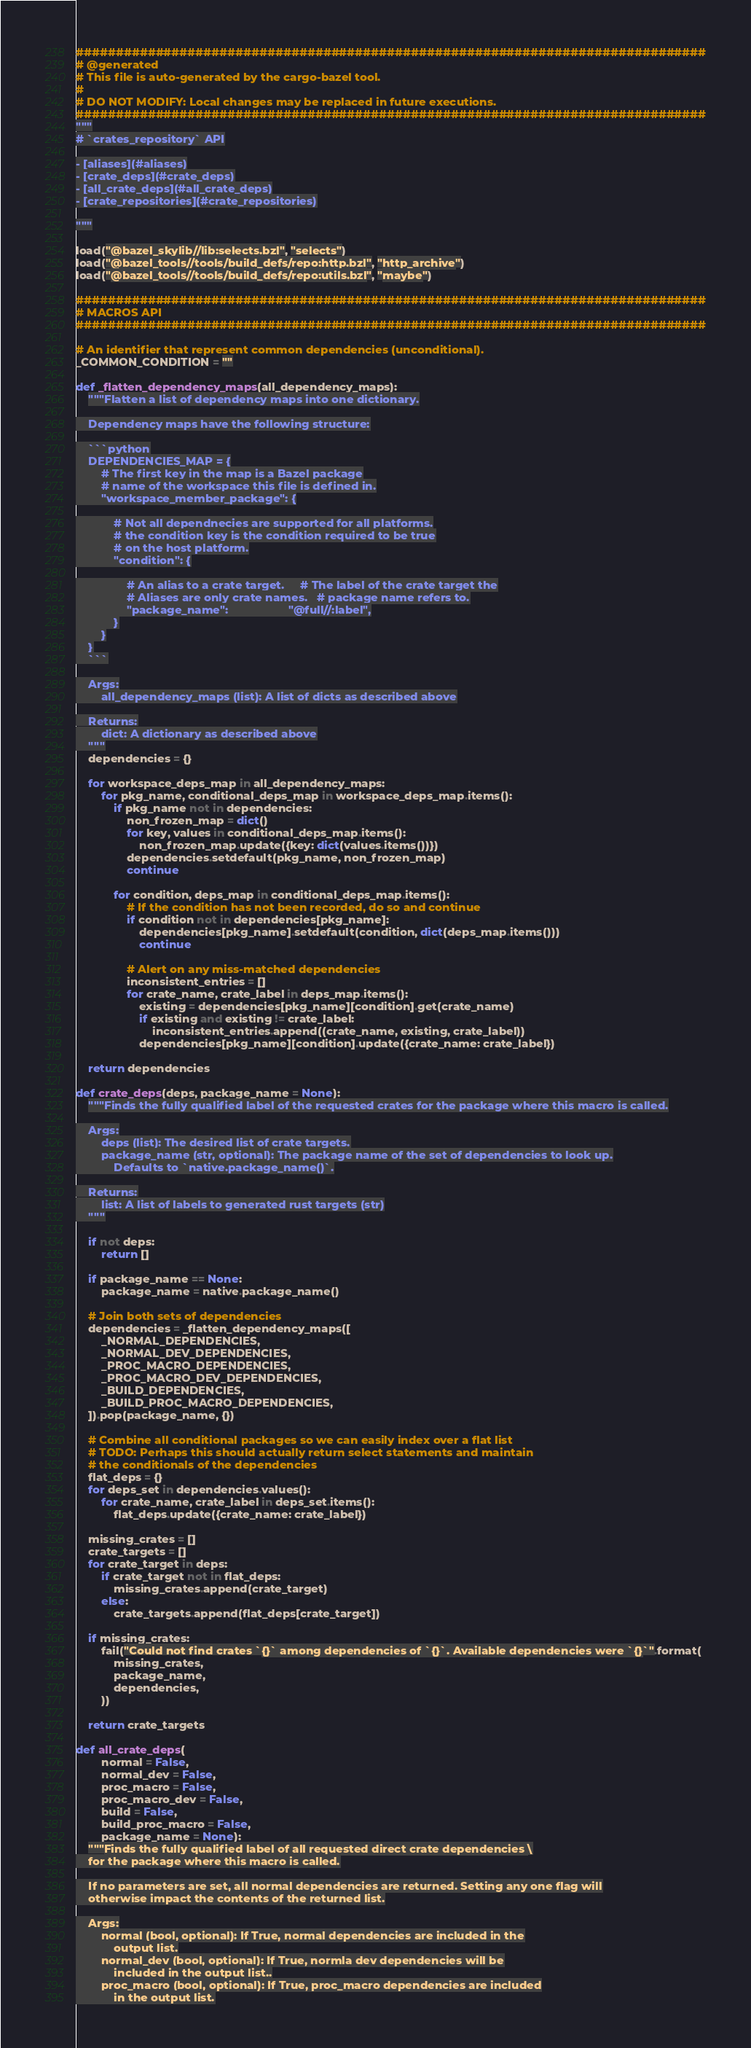<code> <loc_0><loc_0><loc_500><loc_500><_Python_>###############################################################################
# @generated
# This file is auto-generated by the cargo-bazel tool.
#
# DO NOT MODIFY: Local changes may be replaced in future executions.
###############################################################################
"""
# `crates_repository` API

- [aliases](#aliases)
- [crate_deps](#crate_deps)
- [all_crate_deps](#all_crate_deps)
- [crate_repositories](#crate_repositories)

"""

load("@bazel_skylib//lib:selects.bzl", "selects")
load("@bazel_tools//tools/build_defs/repo:http.bzl", "http_archive")
load("@bazel_tools//tools/build_defs/repo:utils.bzl", "maybe")

###############################################################################
# MACROS API
###############################################################################

# An identifier that represent common dependencies (unconditional).
_COMMON_CONDITION = ""

def _flatten_dependency_maps(all_dependency_maps):
    """Flatten a list of dependency maps into one dictionary.

    Dependency maps have the following structure:

    ```python
    DEPENDENCIES_MAP = {
        # The first key in the map is a Bazel package
        # name of the workspace this file is defined in.
        "workspace_member_package": {

            # Not all dependnecies are supported for all platforms.
            # the condition key is the condition required to be true
            # on the host platform.
            "condition": {

                # An alias to a crate target.     # The label of the crate target the
                # Aliases are only crate names.   # package name refers to.
                "package_name":                   "@full//:label",
            }
        }
    }
    ```

    Args:
        all_dependency_maps (list): A list of dicts as described above

    Returns:
        dict: A dictionary as described above
    """
    dependencies = {}

    for workspace_deps_map in all_dependency_maps:
        for pkg_name, conditional_deps_map in workspace_deps_map.items():
            if pkg_name not in dependencies:
                non_frozen_map = dict()
                for key, values in conditional_deps_map.items():
                    non_frozen_map.update({key: dict(values.items())})
                dependencies.setdefault(pkg_name, non_frozen_map)
                continue

            for condition, deps_map in conditional_deps_map.items():
                # If the condition has not been recorded, do so and continue
                if condition not in dependencies[pkg_name]:
                    dependencies[pkg_name].setdefault(condition, dict(deps_map.items()))
                    continue

                # Alert on any miss-matched dependencies
                inconsistent_entries = []
                for crate_name, crate_label in deps_map.items():
                    existing = dependencies[pkg_name][condition].get(crate_name)
                    if existing and existing != crate_label:
                        inconsistent_entries.append((crate_name, existing, crate_label))
                    dependencies[pkg_name][condition].update({crate_name: crate_label})

    return dependencies

def crate_deps(deps, package_name = None):
    """Finds the fully qualified label of the requested crates for the package where this macro is called.

    Args:
        deps (list): The desired list of crate targets.
        package_name (str, optional): The package name of the set of dependencies to look up.
            Defaults to `native.package_name()`.

    Returns:
        list: A list of labels to generated rust targets (str)
    """

    if not deps:
        return []

    if package_name == None:
        package_name = native.package_name()

    # Join both sets of dependencies
    dependencies = _flatten_dependency_maps([
        _NORMAL_DEPENDENCIES,
        _NORMAL_DEV_DEPENDENCIES,
        _PROC_MACRO_DEPENDENCIES,
        _PROC_MACRO_DEV_DEPENDENCIES,
        _BUILD_DEPENDENCIES,
        _BUILD_PROC_MACRO_DEPENDENCIES,
    ]).pop(package_name, {})

    # Combine all conditional packages so we can easily index over a flat list
    # TODO: Perhaps this should actually return select statements and maintain
    # the conditionals of the dependencies
    flat_deps = {}
    for deps_set in dependencies.values():
        for crate_name, crate_label in deps_set.items():
            flat_deps.update({crate_name: crate_label})

    missing_crates = []
    crate_targets = []
    for crate_target in deps:
        if crate_target not in flat_deps:
            missing_crates.append(crate_target)
        else:
            crate_targets.append(flat_deps[crate_target])

    if missing_crates:
        fail("Could not find crates `{}` among dependencies of `{}`. Available dependencies were `{}`".format(
            missing_crates,
            package_name,
            dependencies,
        ))

    return crate_targets

def all_crate_deps(
        normal = False,
        normal_dev = False,
        proc_macro = False,
        proc_macro_dev = False,
        build = False,
        build_proc_macro = False,
        package_name = None):
    """Finds the fully qualified label of all requested direct crate dependencies \
    for the package where this macro is called.

    If no parameters are set, all normal dependencies are returned. Setting any one flag will
    otherwise impact the contents of the returned list.

    Args:
        normal (bool, optional): If True, normal dependencies are included in the
            output list.
        normal_dev (bool, optional): If True, normla dev dependencies will be
            included in the output list..
        proc_macro (bool, optional): If True, proc_macro dependencies are included
            in the output list.</code> 